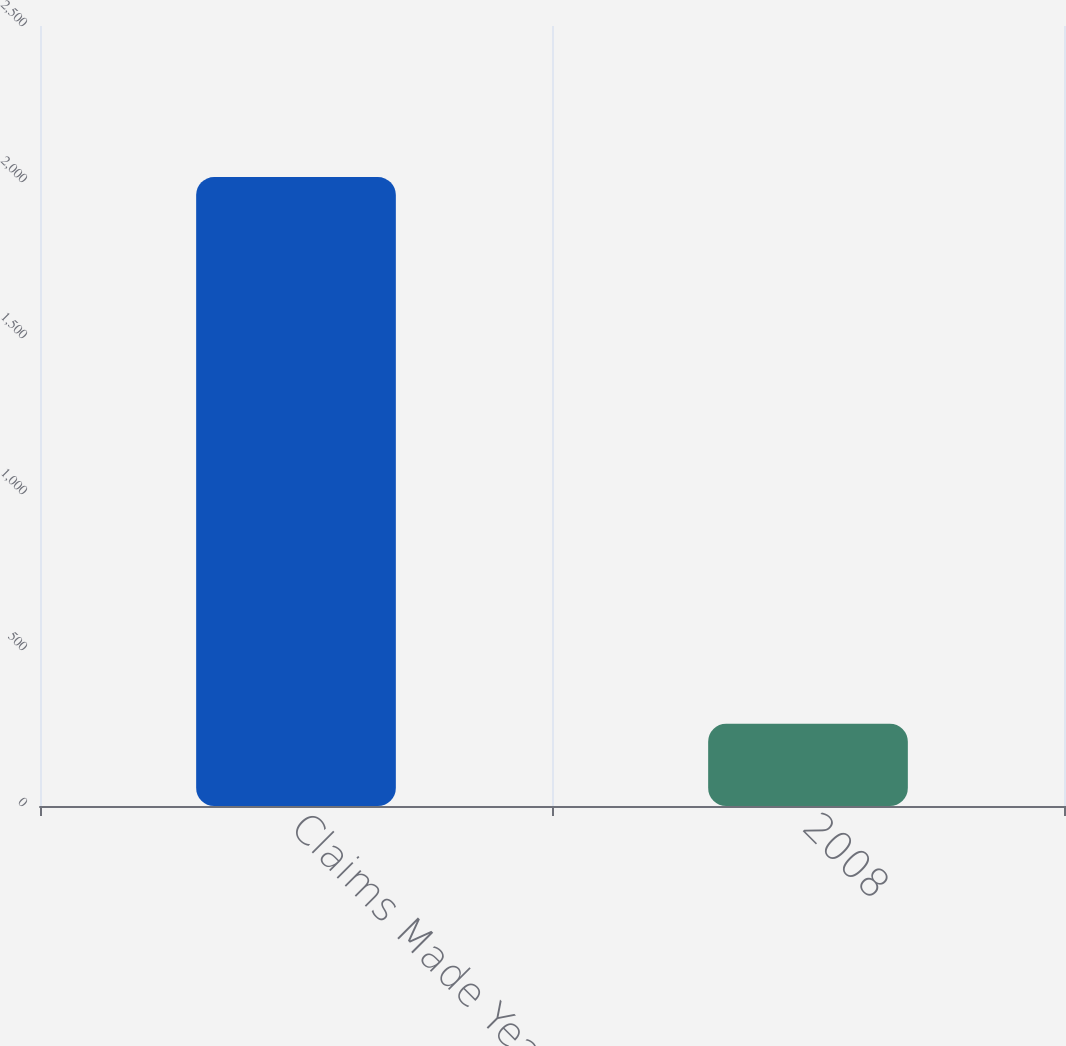Convert chart. <chart><loc_0><loc_0><loc_500><loc_500><bar_chart><fcel>Claims Made Year<fcel>2008<nl><fcel>2016<fcel>264<nl></chart> 